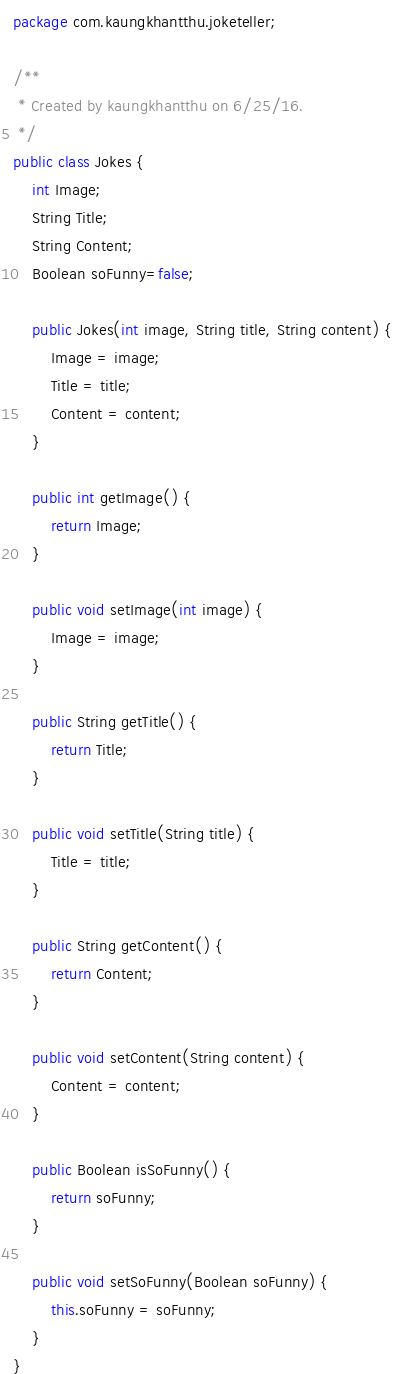Convert code to text. <code><loc_0><loc_0><loc_500><loc_500><_Java_>package com.kaungkhantthu.joketeller;

/**
 * Created by kaungkhantthu on 6/25/16.
 */
public class Jokes {
    int Image;
    String Title;
    String Content;
    Boolean soFunny=false;

    public Jokes(int image, String title, String content) {
        Image = image;
        Title = title;
        Content = content;
    }

    public int getImage() {
        return Image;
    }

    public void setImage(int image) {
        Image = image;
    }

    public String getTitle() {
        return Title;
    }

    public void setTitle(String title) {
        Title = title;
    }

    public String getContent() {
        return Content;
    }

    public void setContent(String content) {
        Content = content;
    }

    public Boolean isSoFunny() {
        return soFunny;
    }

    public void setSoFunny(Boolean soFunny) {
        this.soFunny = soFunny;
    }
}
</code> 